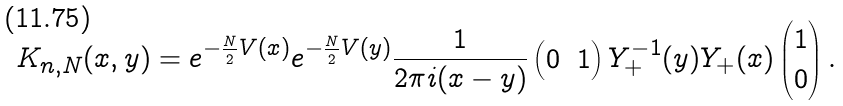<formula> <loc_0><loc_0><loc_500><loc_500>K _ { n , N } ( x , y ) = e ^ { - \frac { N } { 2 } V ( x ) } e ^ { - \frac { N } { 2 } V ( y ) } \frac { 1 } { 2 \pi i ( x - y ) } \begin{pmatrix} 0 & 1 \end{pmatrix} Y _ { + } ^ { - 1 } ( y ) Y _ { + } ( x ) \begin{pmatrix} 1 \\ 0 \end{pmatrix} .</formula> 